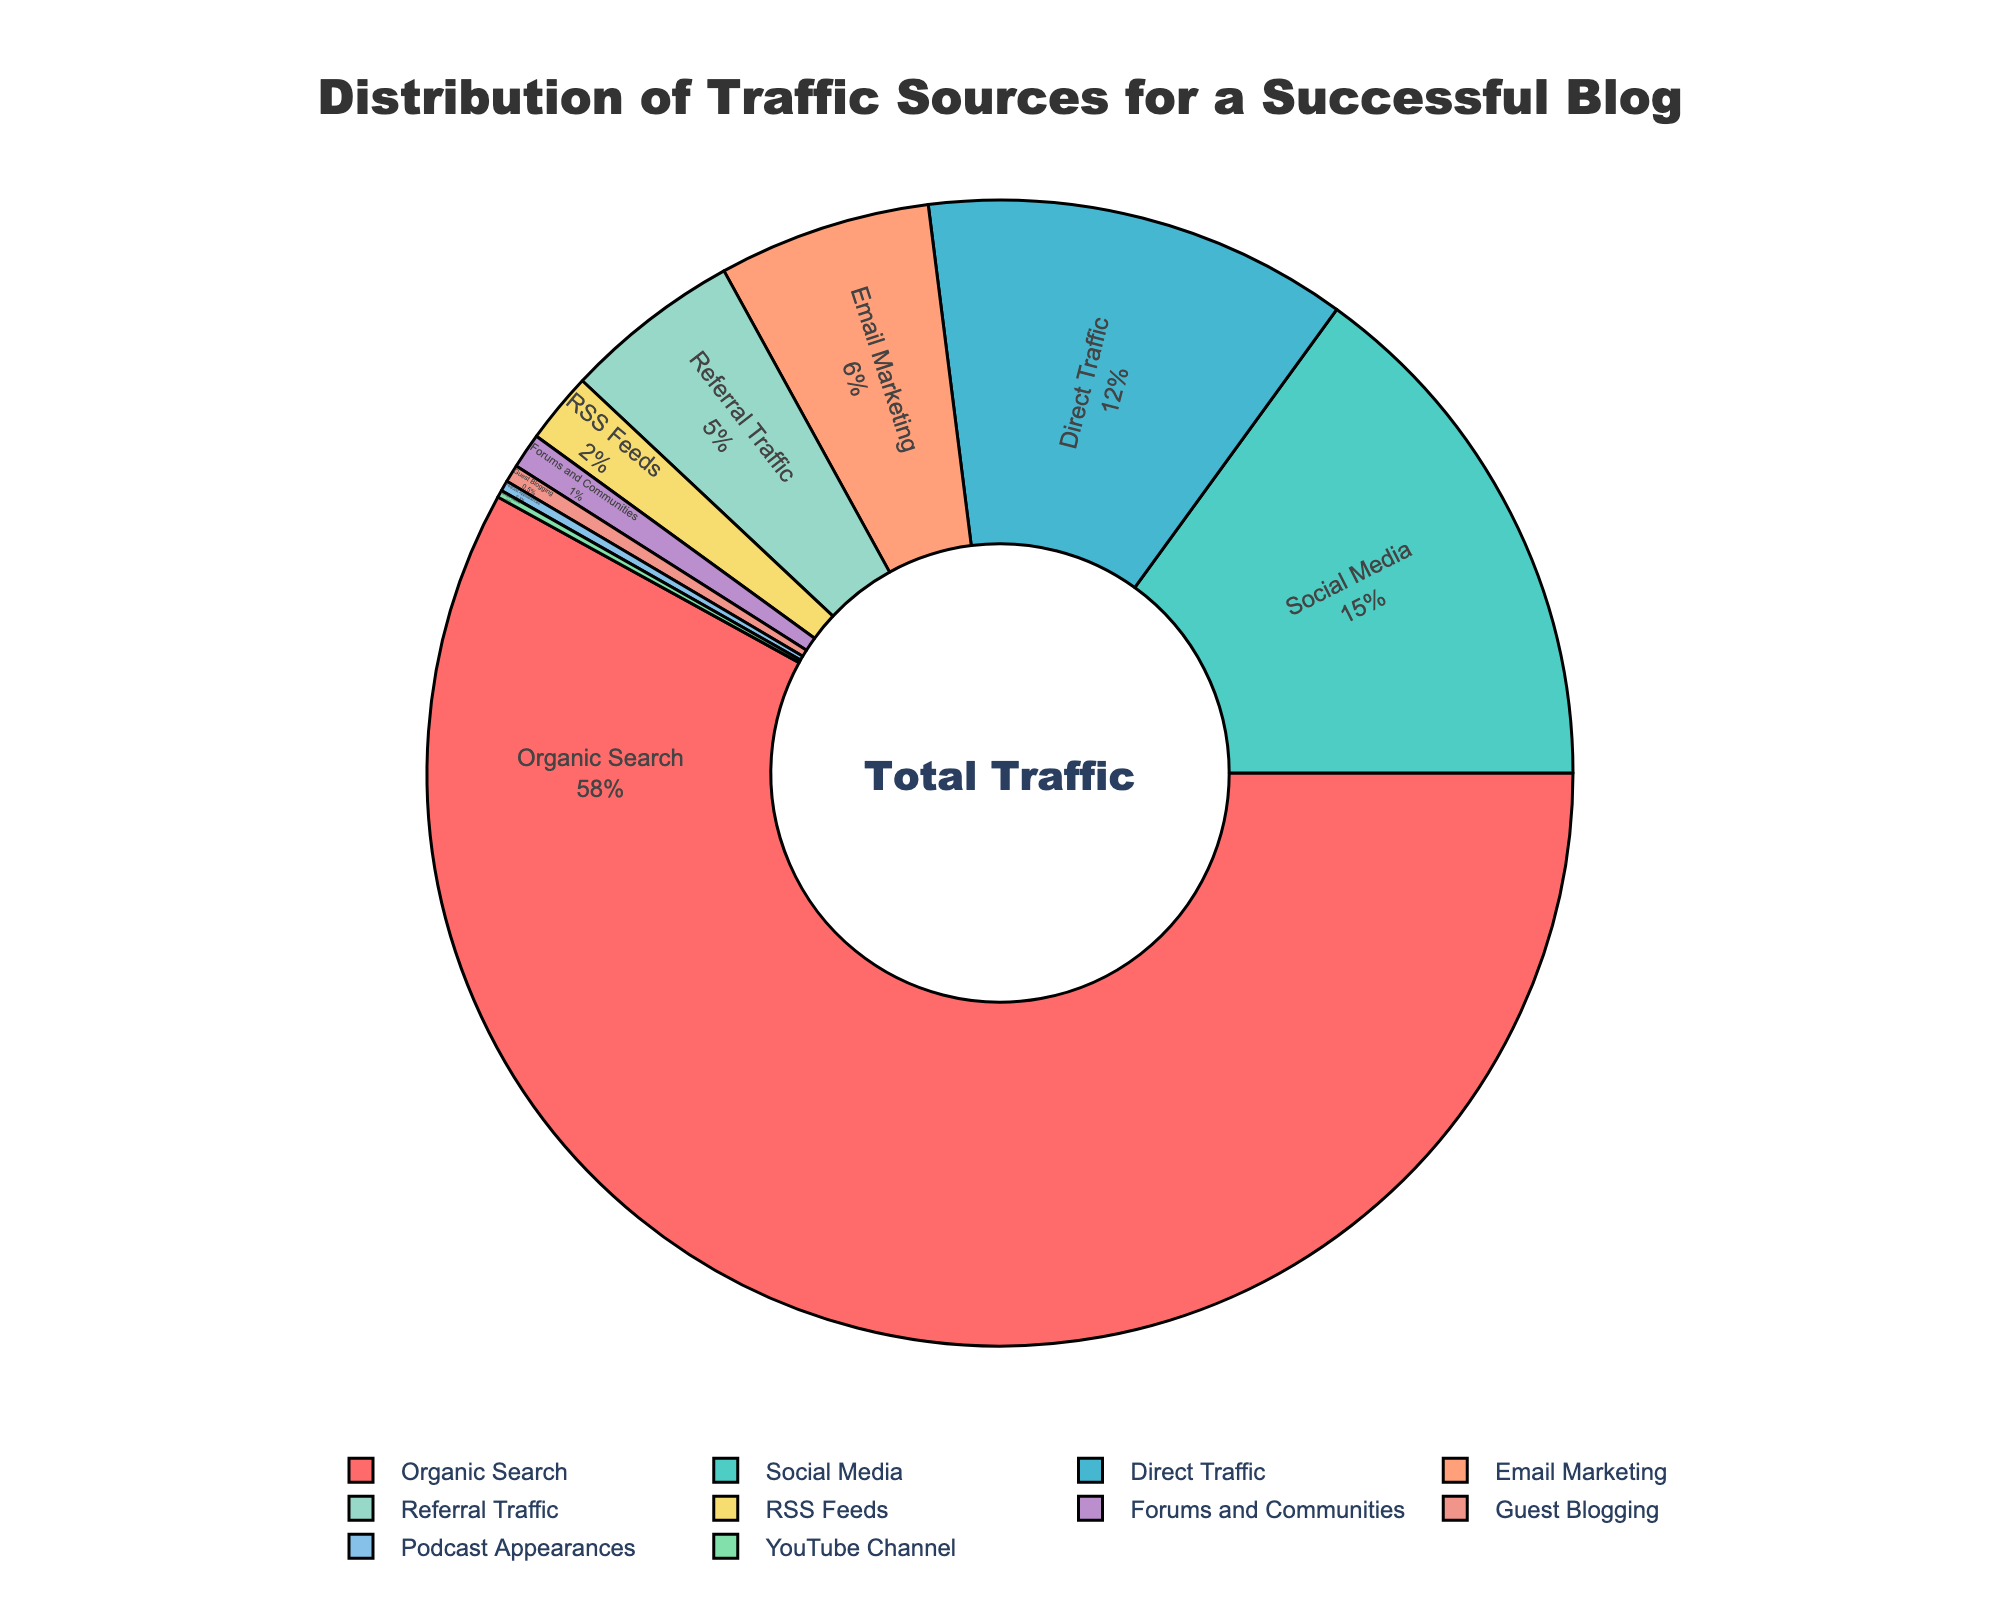What is the largest traffic source? The largest portion of the pie chart occupies the most space and is labeled "Organic Search" with 58%.
Answer: Organic Search What percentage of the traffic comes from Social Media and Direct Traffic combined? Add the percentages of Social Media (15%) and Direct Traffic (12%). 15 + 12 = 27
Answer: 27% Which traffic source contributes the least to the blog? The smallest portion of the pie chart, labeled "YouTube Channel," has the lowest percentage of 0.2%.
Answer: YouTube Channel How much larger is the percentage of traffic from Organic Search compared to Social Media? Subtract the percentage of Social Media (15%) from Organic Search (58%). 58 - 15 = 43
Answer: 43% What is the total percentage of traffic coming from Email Marketing, Referral Traffic, and RSS Feeds combined? Add the percentages: Email Marketing (6%), Referral Traffic (5%), and RSS Feeds (2%). 6 + 5 + 2 = 13
Answer: 13% Which source has a larger percentage of traffic, Forums and Communities or Guest Blogging? Compare the percentages: Forums and Communities (1%) is larger than Guest Blogging (0.5%).
Answer: Forums and Communities What is the difference between the traffic percentages of Direct Traffic and Referral Traffic? Subtract Referral Traffic (5%) from Direct Traffic (12%). 12 - 5 = 7
Answer: 7% Which color represents Email Marketing in the pie chart? The portion of the pie chart labeled "Email Marketing" is the fifth color in order (based on given colors), which is yellow.
Answer: Yellow What percentage of traffic comes from sources contributing less than 1% individually? Sum the percentages of sources with less than 1% individually: Guest Blogging (0.5%), Podcast Appearances (0.3%), YouTube Channel (0.2%). 0.5 + 0.3 + 0.2 = 1
Answer: 1% What is the sum of traffic percentages from non-organic sources? Subtract the percentage of Organic Search (58%) from the total percentage (100%). 100 - 58 = 42
Answer: 42% 